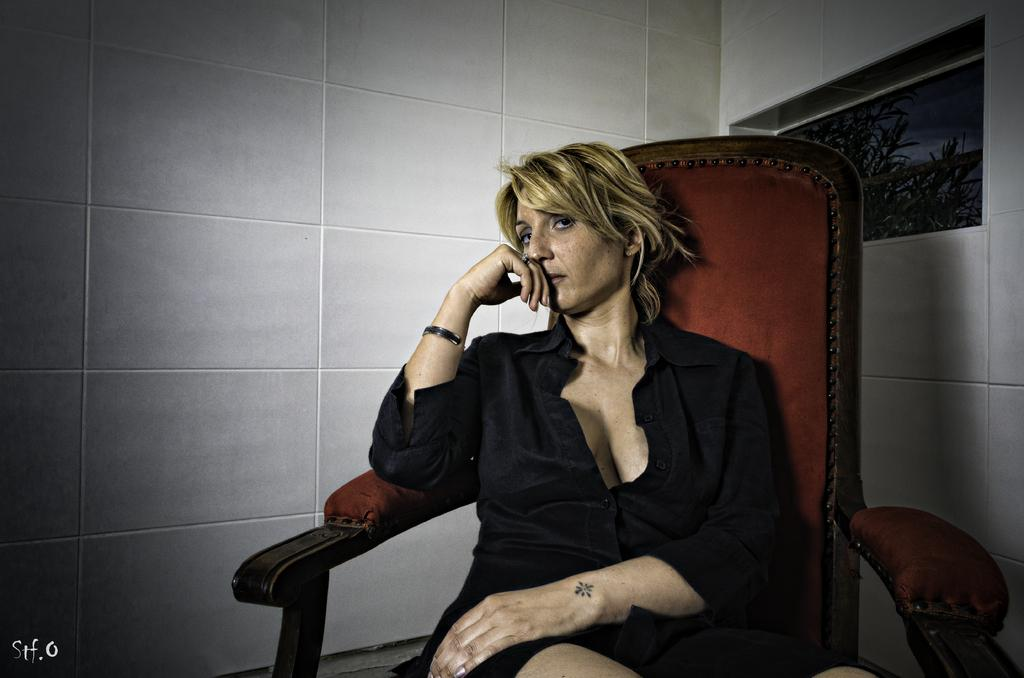What is the woman in the image doing? The woman is sitting on a chair in the image. What can be seen in the background of the image? Walls, trees, and the sky are visible in the background of the image. How many fingers does the doll have in the image? There is no doll present in the image, so it is not possible to determine the number of fingers it might have. 